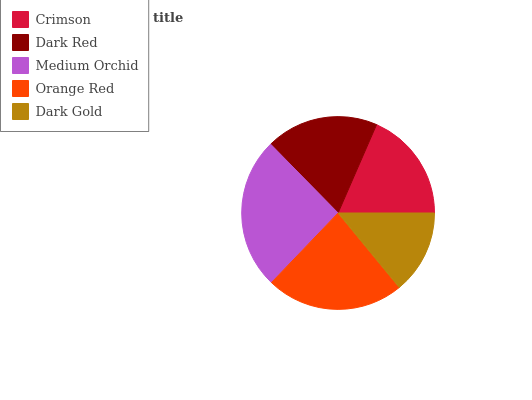Is Dark Gold the minimum?
Answer yes or no. Yes. Is Medium Orchid the maximum?
Answer yes or no. Yes. Is Dark Red the minimum?
Answer yes or no. No. Is Dark Red the maximum?
Answer yes or no. No. Is Dark Red greater than Crimson?
Answer yes or no. Yes. Is Crimson less than Dark Red?
Answer yes or no. Yes. Is Crimson greater than Dark Red?
Answer yes or no. No. Is Dark Red less than Crimson?
Answer yes or no. No. Is Dark Red the high median?
Answer yes or no. Yes. Is Dark Red the low median?
Answer yes or no. Yes. Is Orange Red the high median?
Answer yes or no. No. Is Dark Gold the low median?
Answer yes or no. No. 